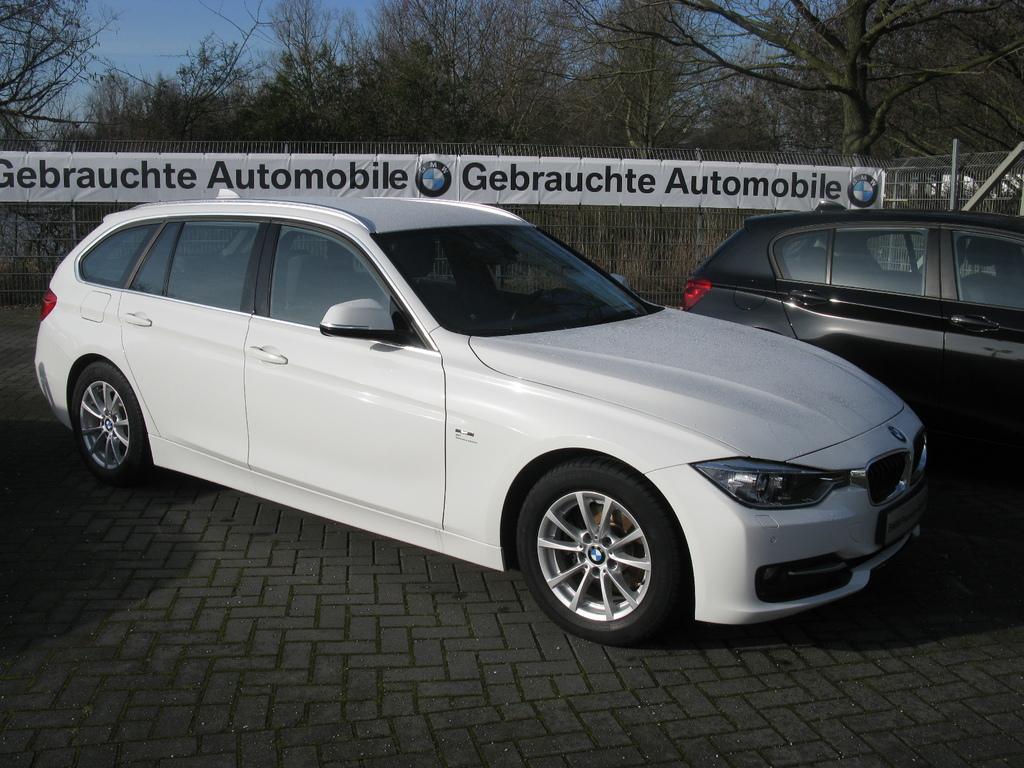In one or two sentences, can you explain what this image depicts? In this image we can see cars. In the back there is a banner with some text and logos. Also there are railings. In the background there are trees and there is sky. 